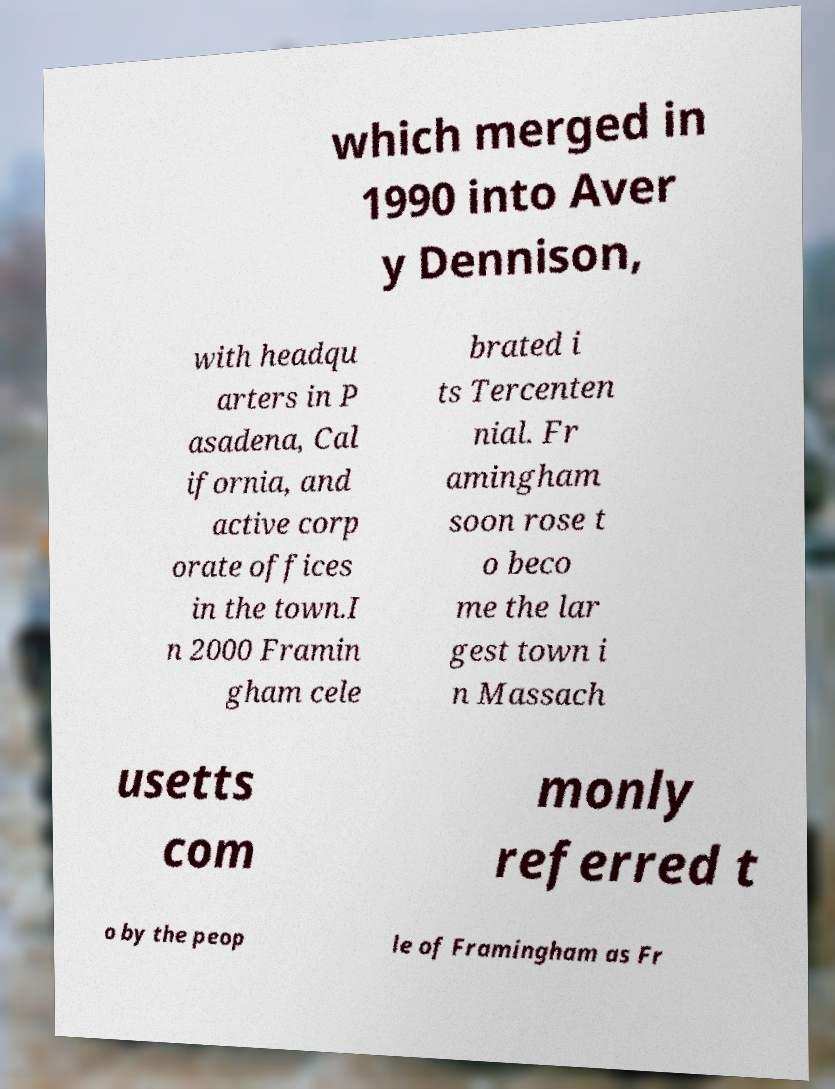Can you read and provide the text displayed in the image?This photo seems to have some interesting text. Can you extract and type it out for me? which merged in 1990 into Aver y Dennison, with headqu arters in P asadena, Cal ifornia, and active corp orate offices in the town.I n 2000 Framin gham cele brated i ts Tercenten nial. Fr amingham soon rose t o beco me the lar gest town i n Massach usetts com monly referred t o by the peop le of Framingham as Fr 